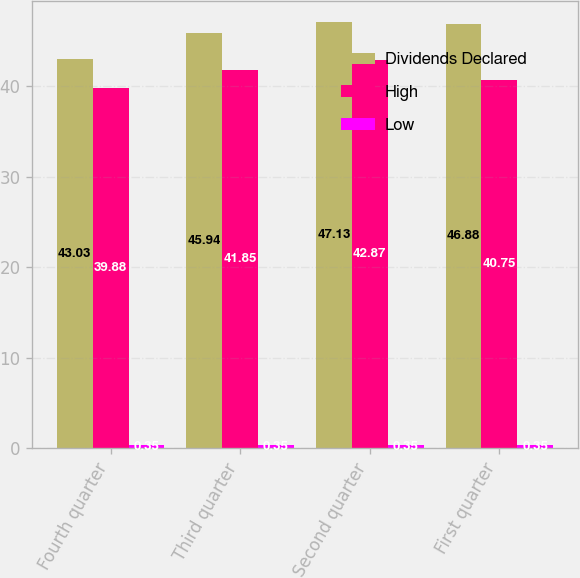Convert chart to OTSL. <chart><loc_0><loc_0><loc_500><loc_500><stacked_bar_chart><ecel><fcel>Fourth quarter<fcel>Third quarter<fcel>Second quarter<fcel>First quarter<nl><fcel>Dividends Declared<fcel>43.03<fcel>45.94<fcel>47.13<fcel>46.88<nl><fcel>High<fcel>39.88<fcel>41.85<fcel>42.87<fcel>40.75<nl><fcel>Low<fcel>0.35<fcel>0.35<fcel>0.35<fcel>0.35<nl></chart> 